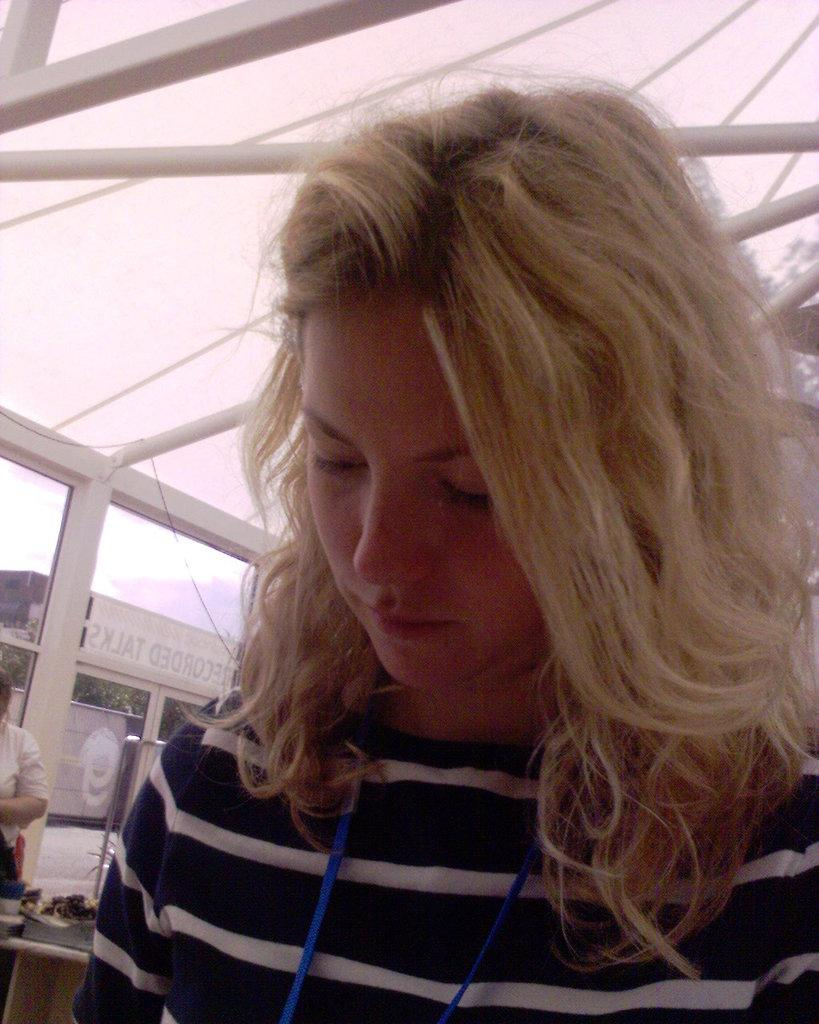Who is present in the image? There is a woman and another person in the image. Can you describe the background of the image? The sky is visible in the background of the image. What type of writing can be seen on the woman's shirt in the image? There is no writing visible on the woman's shirt in the image. How many balls are being juggled by the other person in the image? There are no balls present in the image; the other person is not juggling anything. 